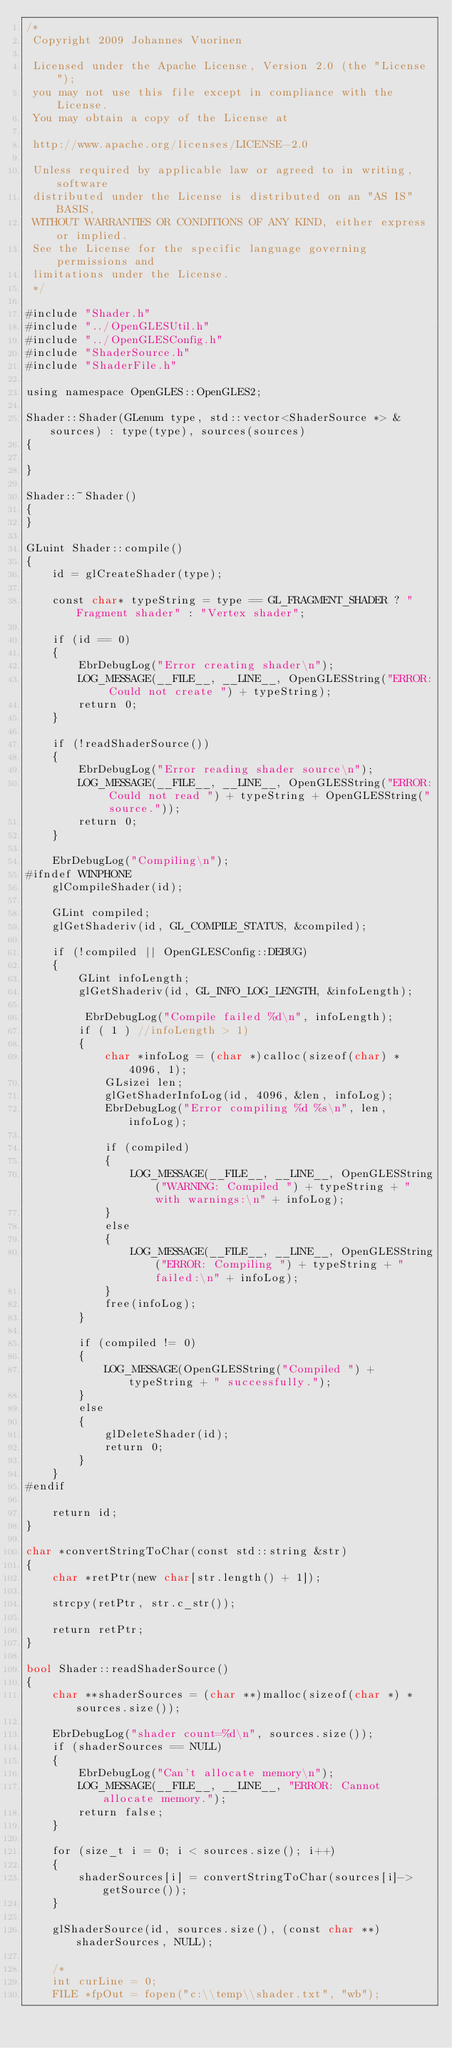<code> <loc_0><loc_0><loc_500><loc_500><_ObjectiveC_>/*
 Copyright 2009 Johannes Vuorinen
 
 Licensed under the Apache License, Version 2.0 (the "License");
 you may not use this file except in compliance with the License.
 You may obtain a copy of the License at 
 
 http://www.apache.org/licenses/LICENSE-2.0 
 
 Unless required by applicable law or agreed to in writing, software
 distributed under the License is distributed on an "AS IS" BASIS,
 WITHOUT WARRANTIES OR CONDITIONS OF ANY KIND, either express or implied.
 See the License for the specific language governing permissions and
 limitations under the License.
 */

#include "Shader.h"
#include "../OpenGLESUtil.h"
#include "../OpenGLESConfig.h"
#include "ShaderSource.h"
#include "ShaderFile.h"

using namespace OpenGLES::OpenGLES2;

Shader::Shader(GLenum type, std::vector<ShaderSource *> &sources) : type(type), sources(sources)
{

}

Shader::~Shader()
{
}

GLuint Shader::compile() 
{
    id = glCreateShader(type);

    const char* typeString = type == GL_FRAGMENT_SHADER ? "Fragment shader" : "Vertex shader";

    if (id == 0) 
    {
        EbrDebugLog("Error creating shader\n");
        LOG_MESSAGE(__FILE__, __LINE__, OpenGLESString("ERROR: Could not create ") + typeString);
        return 0;
    }

    if (!readShaderSource()) 
    {
        EbrDebugLog("Error reading shader source\n");
        LOG_MESSAGE(__FILE__, __LINE__, OpenGLESString("ERROR: Could not read ") + typeString + OpenGLESString(" source."));
        return 0;
    }

    EbrDebugLog("Compiling\n");
#ifndef WINPHONE
    glCompileShader(id);

    GLint compiled;
    glGetShaderiv(id, GL_COMPILE_STATUS, &compiled);

    if (!compiled || OpenGLESConfig::DEBUG)
    {
        GLint infoLength;
        glGetShaderiv(id, GL_INFO_LOG_LENGTH, &infoLength);

         EbrDebugLog("Compile failed %d\n", infoLength);
        if ( 1 ) //infoLength > 1)
        {
            char *infoLog = (char *)calloc(sizeof(char) * 4096, 1);
            GLsizei len;
            glGetShaderInfoLog(id, 4096, &len, infoLog);
            EbrDebugLog("Error compiling %d %s\n", len, infoLog);

            if (compiled) 
            {
                LOG_MESSAGE(__FILE__, __LINE__, OpenGLESString("WARNING: Compiled ") + typeString + " with warnings:\n" + infoLog);
            } 
            else 
            {
                LOG_MESSAGE(__FILE__, __LINE__, OpenGLESString("ERROR: Compiling ") + typeString + " failed:\n" + infoLog);
            }
            free(infoLog);
        }

        if (compiled != 0)
        {
            LOG_MESSAGE(OpenGLESString("Compiled ") + typeString + " successfully.");
        }
        else
        {
            glDeleteShader(id);
            return 0;
        }
    }
#endif

    return id;
}

char *convertStringToChar(const std::string &str)
{
    char *retPtr(new char[str.length() + 1]);

    strcpy(retPtr, str.c_str());

    return retPtr;
}

bool Shader::readShaderSource()
{
    char **shaderSources = (char **)malloc(sizeof(char *) * sources.size());

    EbrDebugLog("shader count=%d\n", sources.size());
    if (shaderSources == NULL)
    {
        EbrDebugLog("Can't allocate memory\n");
        LOG_MESSAGE(__FILE__, __LINE__, "ERROR: Cannot allocate memory.");
        return false;
    }

    for (size_t i = 0; i < sources.size(); i++) 
    {
        shaderSources[i] = convertStringToChar(sources[i]->getSource());
    }

    glShaderSource(id, sources.size(), (const char **)shaderSources, NULL);

    /*
    int curLine = 0;
    FILE *fpOut = fopen("c:\\temp\\shader.txt", "wb");
</code> 